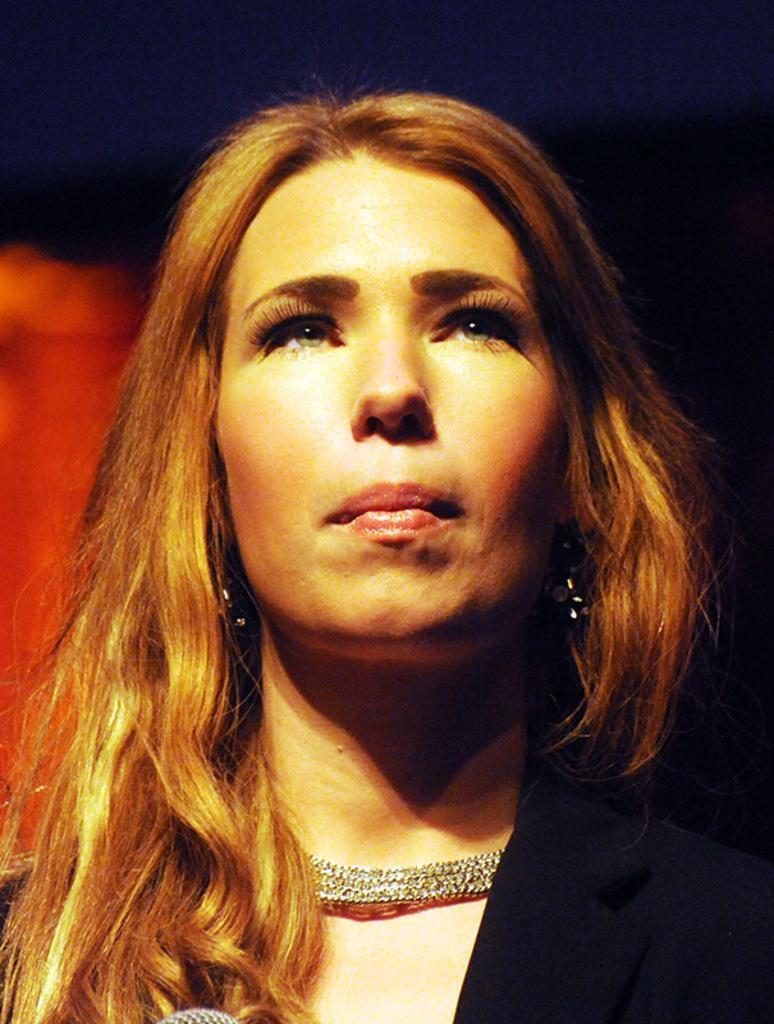In one or two sentences, can you explain what this image depicts? In this picture we can see a woman, she wore a necklace, we can see a blurry background. 